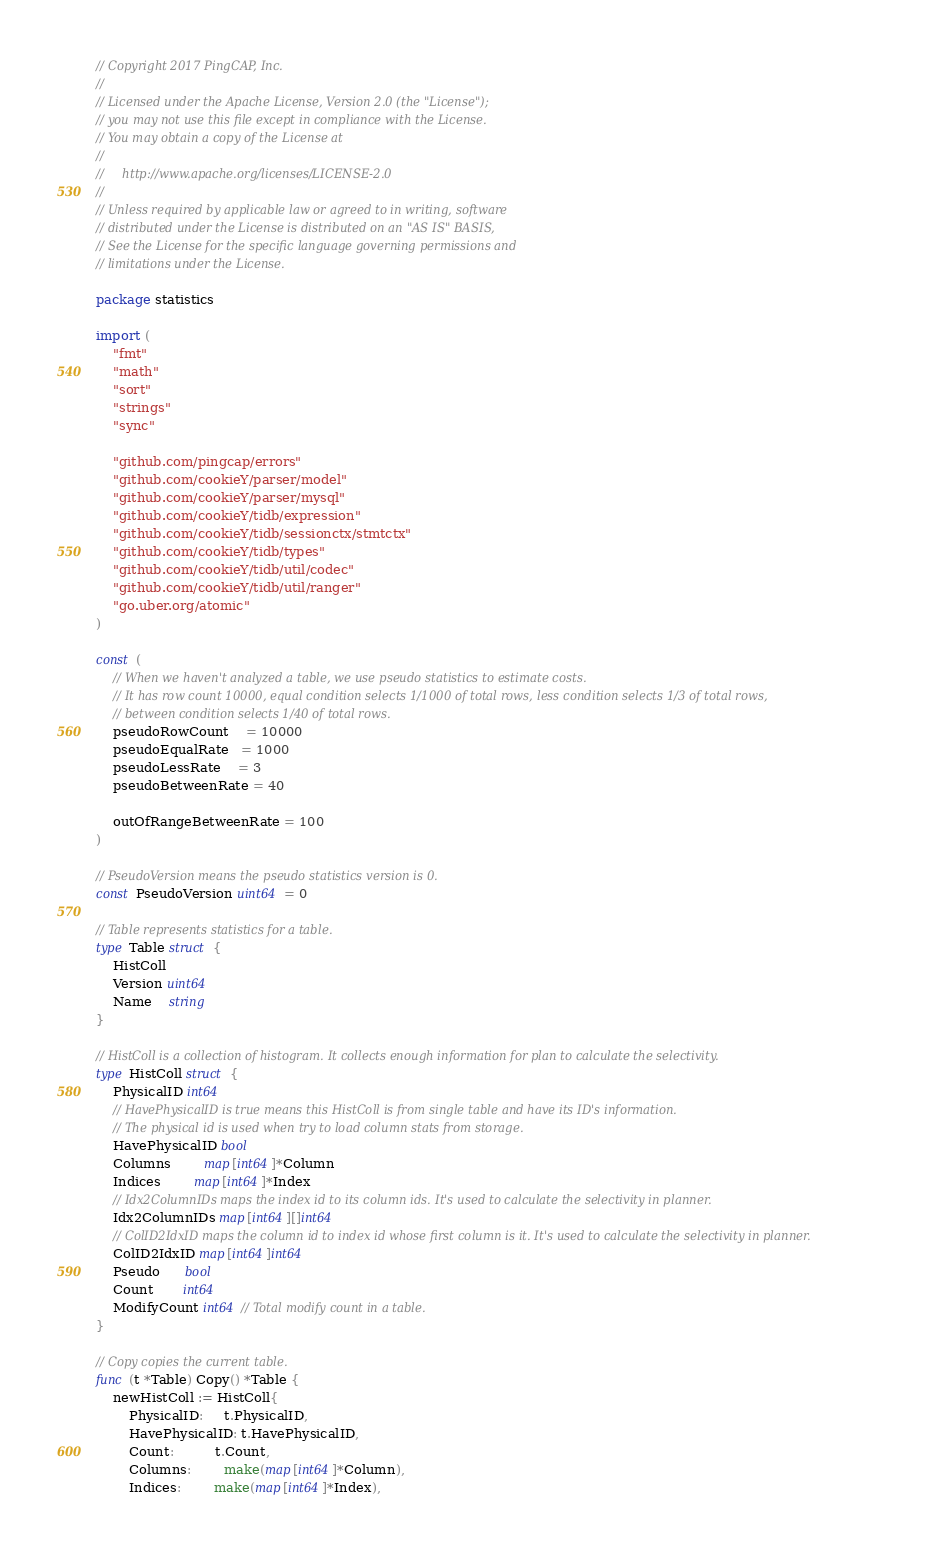Convert code to text. <code><loc_0><loc_0><loc_500><loc_500><_Go_>// Copyright 2017 PingCAP, Inc.
//
// Licensed under the Apache License, Version 2.0 (the "License");
// you may not use this file except in compliance with the License.
// You may obtain a copy of the License at
//
//     http://www.apache.org/licenses/LICENSE-2.0
//
// Unless required by applicable law or agreed to in writing, software
// distributed under the License is distributed on an "AS IS" BASIS,
// See the License for the specific language governing permissions and
// limitations under the License.

package statistics

import (
	"fmt"
	"math"
	"sort"
	"strings"
	"sync"

	"github.com/pingcap/errors"
	"github.com/cookieY/parser/model"
	"github.com/cookieY/parser/mysql"
	"github.com/cookieY/tidb/expression"
	"github.com/cookieY/tidb/sessionctx/stmtctx"
	"github.com/cookieY/tidb/types"
	"github.com/cookieY/tidb/util/codec"
	"github.com/cookieY/tidb/util/ranger"
	"go.uber.org/atomic"
)

const (
	// When we haven't analyzed a table, we use pseudo statistics to estimate costs.
	// It has row count 10000, equal condition selects 1/1000 of total rows, less condition selects 1/3 of total rows,
	// between condition selects 1/40 of total rows.
	pseudoRowCount    = 10000
	pseudoEqualRate   = 1000
	pseudoLessRate    = 3
	pseudoBetweenRate = 40

	outOfRangeBetweenRate = 100
)

// PseudoVersion means the pseudo statistics version is 0.
const PseudoVersion uint64 = 0

// Table represents statistics for a table.
type Table struct {
	HistColl
	Version uint64
	Name    string
}

// HistColl is a collection of histogram. It collects enough information for plan to calculate the selectivity.
type HistColl struct {
	PhysicalID int64
	// HavePhysicalID is true means this HistColl is from single table and have its ID's information.
	// The physical id is used when try to load column stats from storage.
	HavePhysicalID bool
	Columns        map[int64]*Column
	Indices        map[int64]*Index
	// Idx2ColumnIDs maps the index id to its column ids. It's used to calculate the selectivity in planner.
	Idx2ColumnIDs map[int64][]int64
	// ColID2IdxID maps the column id to index id whose first column is it. It's used to calculate the selectivity in planner.
	ColID2IdxID map[int64]int64
	Pseudo      bool
	Count       int64
	ModifyCount int64 // Total modify count in a table.
}

// Copy copies the current table.
func (t *Table) Copy() *Table {
	newHistColl := HistColl{
		PhysicalID:     t.PhysicalID,
		HavePhysicalID: t.HavePhysicalID,
		Count:          t.Count,
		Columns:        make(map[int64]*Column),
		Indices:        make(map[int64]*Index),</code> 